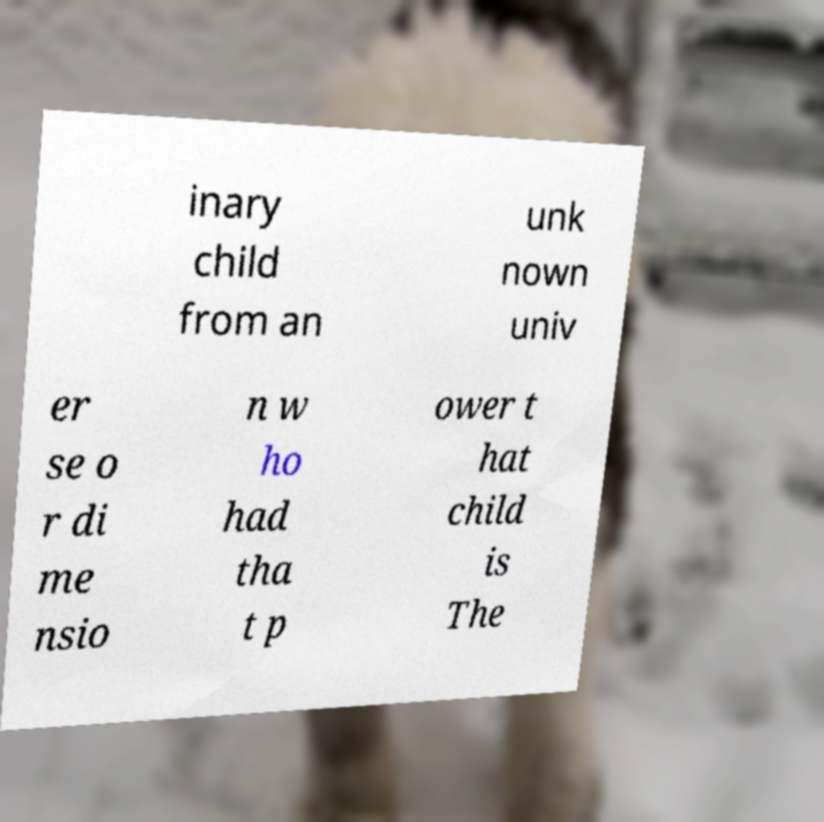Please identify and transcribe the text found in this image. inary child from an unk nown univ er se o r di me nsio n w ho had tha t p ower t hat child is The 